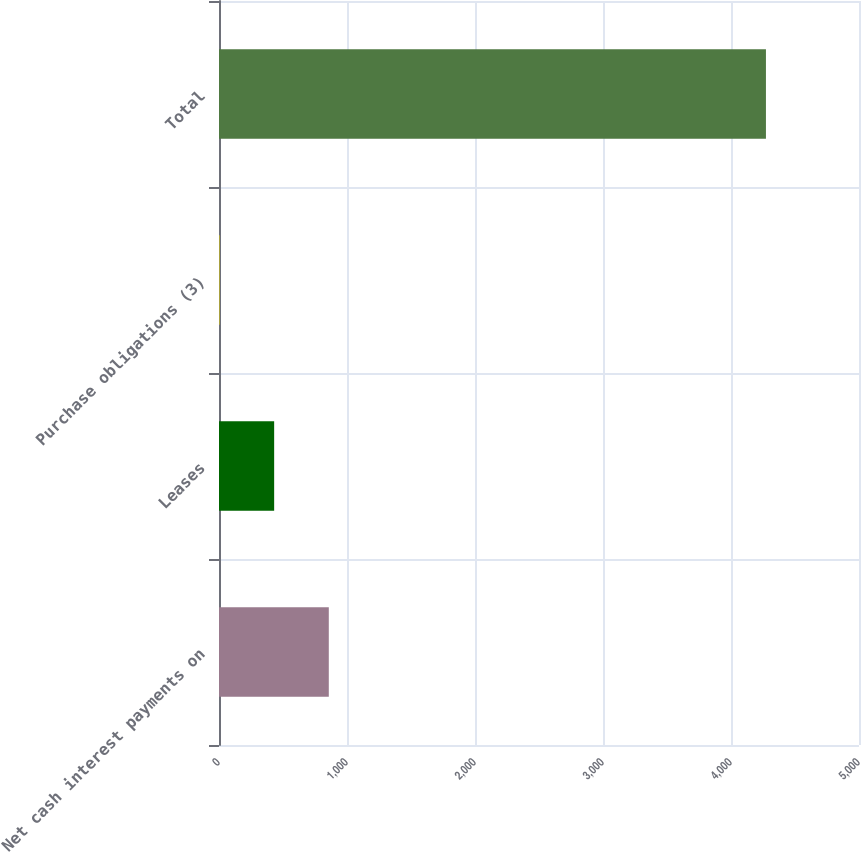Convert chart to OTSL. <chart><loc_0><loc_0><loc_500><loc_500><bar_chart><fcel>Net cash interest payments on<fcel>Leases<fcel>Purchase obligations (3)<fcel>Total<nl><fcel>857.8<fcel>430.9<fcel>4<fcel>4273<nl></chart> 